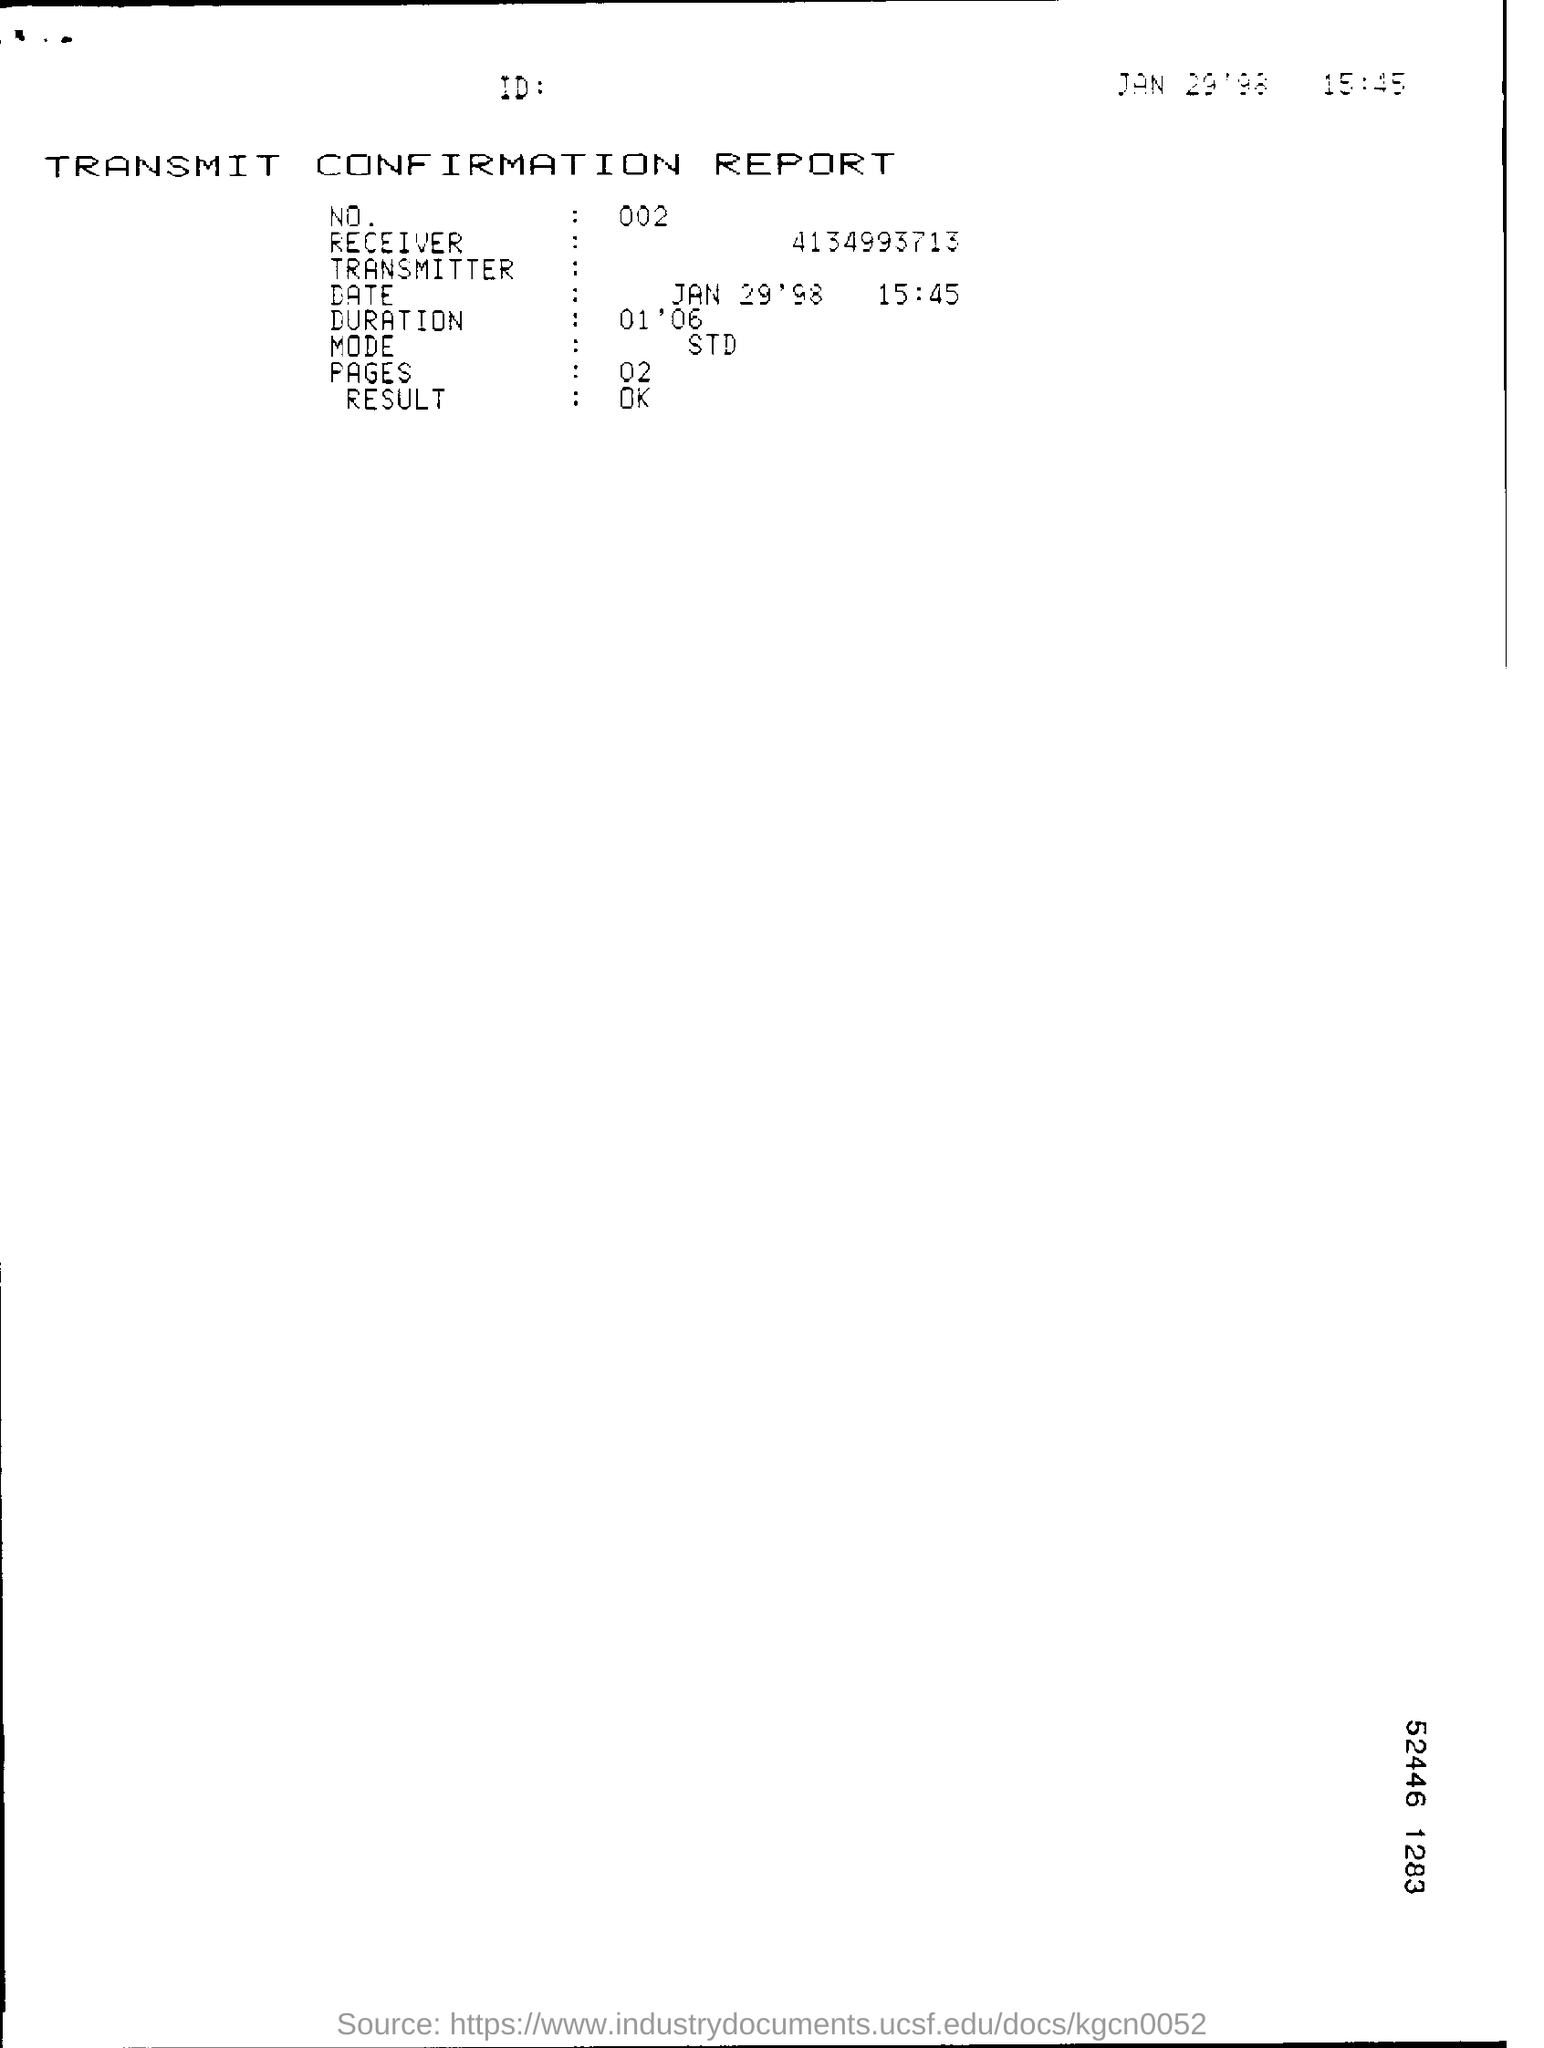What is the mode of transmission?
Ensure brevity in your answer.  STD. 